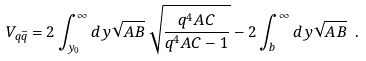Convert formula to latex. <formula><loc_0><loc_0><loc_500><loc_500>V _ { q \bar { q } } = 2 \int _ { y _ { 0 } } ^ { \infty } d y \sqrt { A B } \, \sqrt { \frac { q ^ { 4 } A C } { q ^ { 4 } A C - 1 } } - 2 \int _ { b } ^ { \infty } d y \sqrt { A B } \ .</formula> 